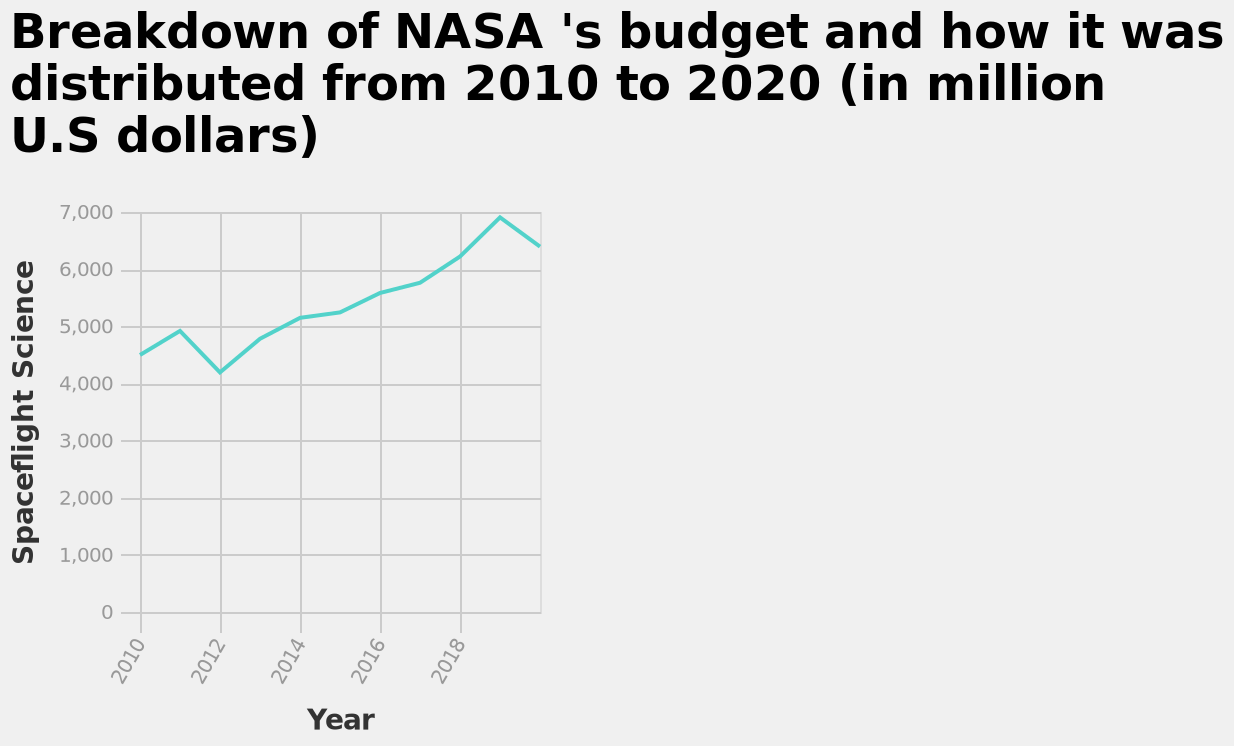<image>
In what unit is the budget represented on the y-axis of the line chart? The budget is represented in million U.S dollars on the y-axis of the line chart. What is the range of values shown on the y-axis of the line chart? The y-axis of the line chart ranges from 0 to 7,000, labeled as "Spaceflight Science". 